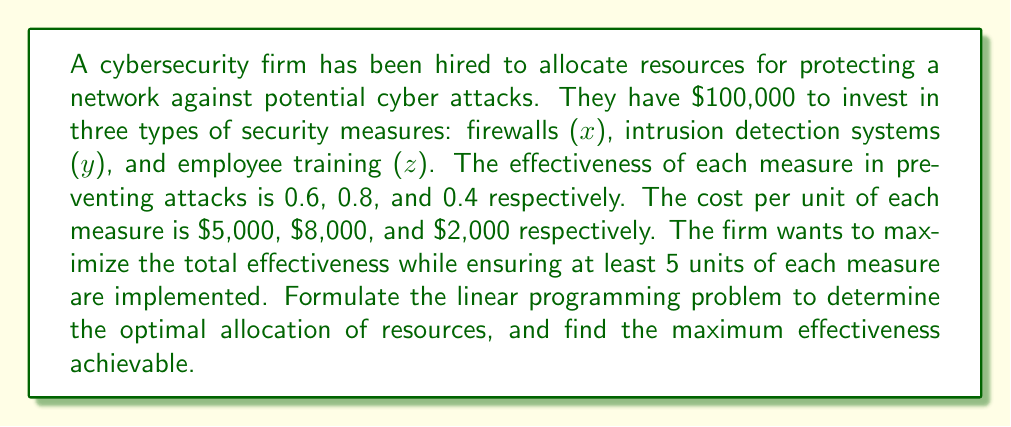What is the answer to this math problem? Let's approach this problem step-by-step:

1) Define the objective function:
   We want to maximize the total effectiveness, which is given by:
   $$\text{Maximize } Z = 0.6x + 0.8y + 0.4z$$

2) Identify the constraints:
   a) Budget constraint: The total cost cannot exceed $100,000
      $$5000x + 8000y + 2000z \leq 100000$$
   
   b) Minimum units constraint: At least 5 units of each measure
      $$x \geq 5$$
      $$y \geq 5$$
      $$z \geq 5$$
   
   c) Non-negativity constraint:
      $$x, y, z \geq 0$$

3) Formulate the complete linear programming problem:
   $$\text{Maximize } Z = 0.6x + 0.8y + 0.4z$$
   Subject to:
   $$5000x + 8000y + 2000z \leq 100000$$
   $$x \geq 5$$
   $$y \geq 5$$
   $$z \geq 5$$
   $$x, y, z \geq 0$$

4) To solve this, we can use the simplex method or a linear programming solver. However, we can make some observations:
   - The minimum requirement (5 units each) costs: $5(5000) + 5(8000) + 5(2000) = 75000$
   - This leaves $25000 for additional allocation

5) Given the coefficients in the objective function, it's most effective to allocate the remaining budget to y (intrusion detection systems), as it has the highest effectiveness per dollar (0.8/8000 = 0.0001).

6) We can allocate 3 more units to y: $3 * 8000 = 24000$, which is within our remaining budget.

7) The final allocation would be:
   x = 5, y = 8, z = 5

8) The maximum effectiveness achievable is:
   $$Z = 0.6(5) + 0.8(8) + 0.4(5) = 3 + 6.4 + 2 = 11.4$$
Answer: The optimal allocation is 5 units of firewalls, 8 units of intrusion detection systems, and 5 units of employee training. The maximum effectiveness achievable is 11.4. 